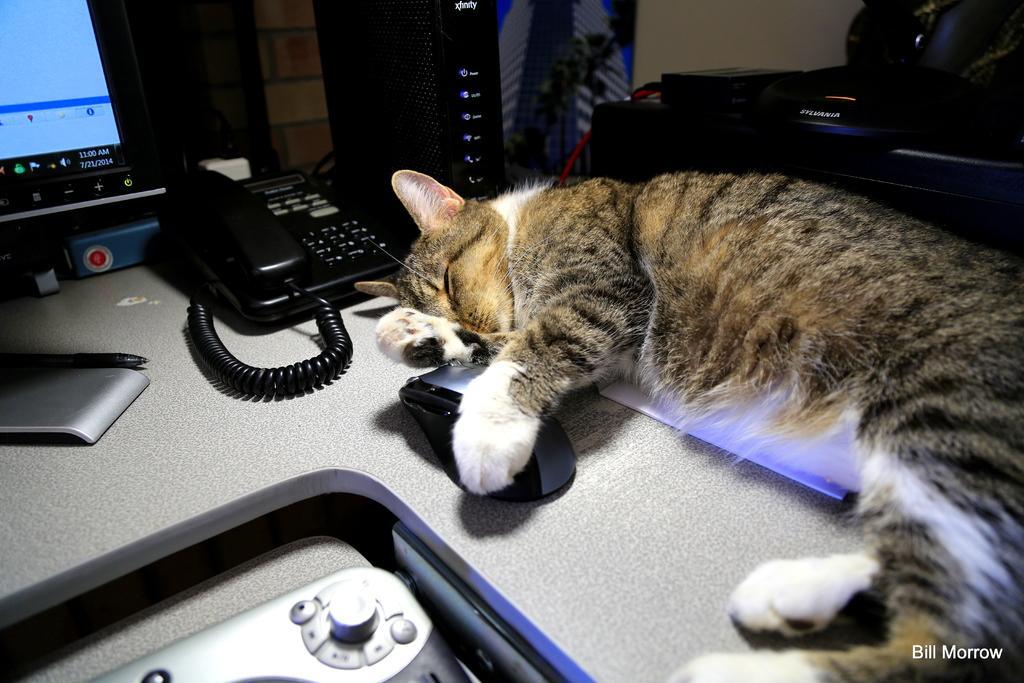Please provide a concise description of this image. In this image we can see a cat, there is a table, on that table, there is a monitor, CPU, mouse, pen, and some other objects, also we can see the wall. 